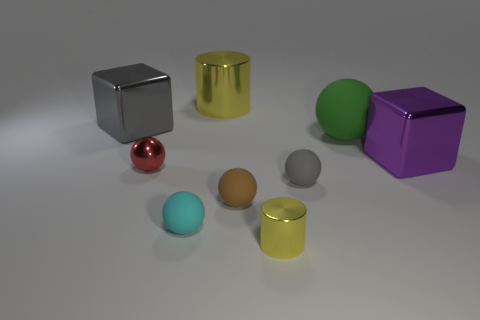Subtract 3 spheres. How many spheres are left? 2 Add 7 large green matte spheres. How many large green matte spheres exist? 8 Add 1 tiny yellow blocks. How many objects exist? 10 Subtract all cyan spheres. How many spheres are left? 4 Subtract all big balls. How many balls are left? 4 Subtract 1 gray cubes. How many objects are left? 8 Subtract all cylinders. How many objects are left? 7 Subtract all red cubes. Subtract all cyan balls. How many cubes are left? 2 Subtract all purple cylinders. How many purple blocks are left? 1 Subtract all gray matte spheres. Subtract all big gray things. How many objects are left? 7 